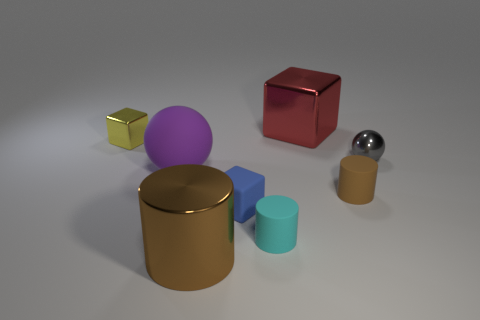What shape is the small gray object that is made of the same material as the large brown cylinder?
Provide a succinct answer. Sphere. There is a metallic thing that is both on the right side of the yellow metallic cube and to the left of the small blue cube; what is its color?
Provide a short and direct response. Brown. Is the material of the brown object that is in front of the small cyan rubber thing the same as the small gray ball?
Offer a very short reply. Yes. Are there fewer purple things that are right of the brown rubber cylinder than gray blocks?
Keep it short and to the point. No. Is there a tiny gray thing made of the same material as the big cylinder?
Your response must be concise. Yes. Does the brown rubber thing have the same size as the metallic block to the right of the brown shiny cylinder?
Make the answer very short. No. Are there any tiny matte cylinders that have the same color as the big metal cylinder?
Your response must be concise. Yes. Does the purple ball have the same material as the tiny brown cylinder?
Your answer should be very brief. Yes. How many big rubber objects are on the right side of the matte ball?
Offer a very short reply. 0. What is the material of the object that is in front of the small gray metallic object and to the left of the metal cylinder?
Make the answer very short. Rubber. 